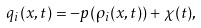<formula> <loc_0><loc_0><loc_500><loc_500>q _ { i } ( x , t ) = - p ( \rho _ { i } ( x , t ) ) + \chi ( t ) ,</formula> 